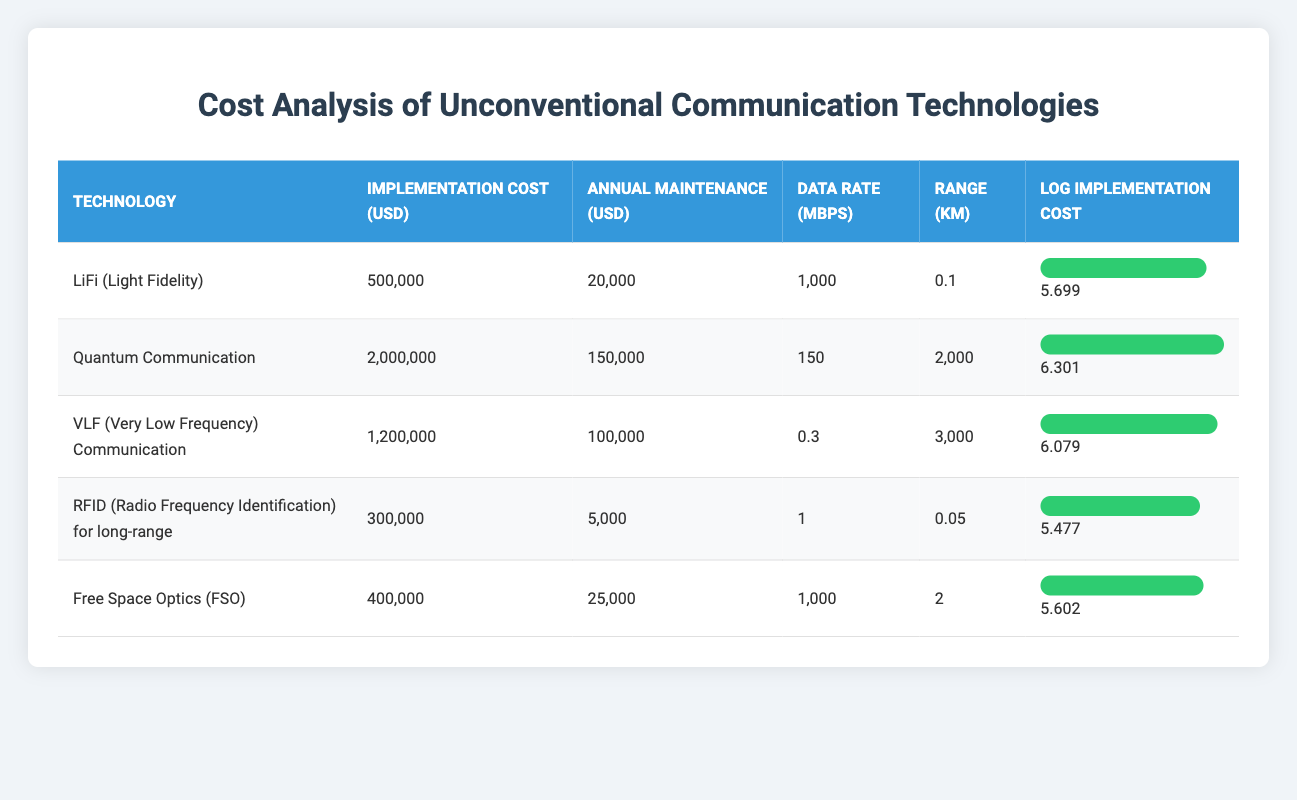What is the implementation cost of Quantum Communication? The implementation cost for Quantum Communication is explicitly listed in the table under the column for Implementation Cost (USD). It shows a value of 2,000,000.
Answer: 2,000,000 Which technology has the highest annual maintenance cost? The annual maintenance costs for each technology are displayed in the table. Quantum Communication has the highest cost at 150,000, compared to other technologies.
Answer: Quantum Communication What is the total implementation cost of all technologies combined? To find the total implementation cost, I add the implementation costs of each technology: 500,000 + 2,000,000 + 1,200,000 + 300,000 + 400,000 = 4,400,000.
Answer: 4,400,000 Which technology has the lowest data rate and what is that rate? The data rates for each technology are listed in the table. The technology with the lowest data rate is VLF (Very Low Frequency) Communication, which is 0.3 Mbps.
Answer: 0.3 Mbps Is Free Space Optics (FSO) cheaper to implement than LiFi? The implementation costs listed in the table show Free Space Optics at 400,000 and LiFi at 500,000, therefore FSO is cheaper than LiFi by comparing these two values.
Answer: Yes 